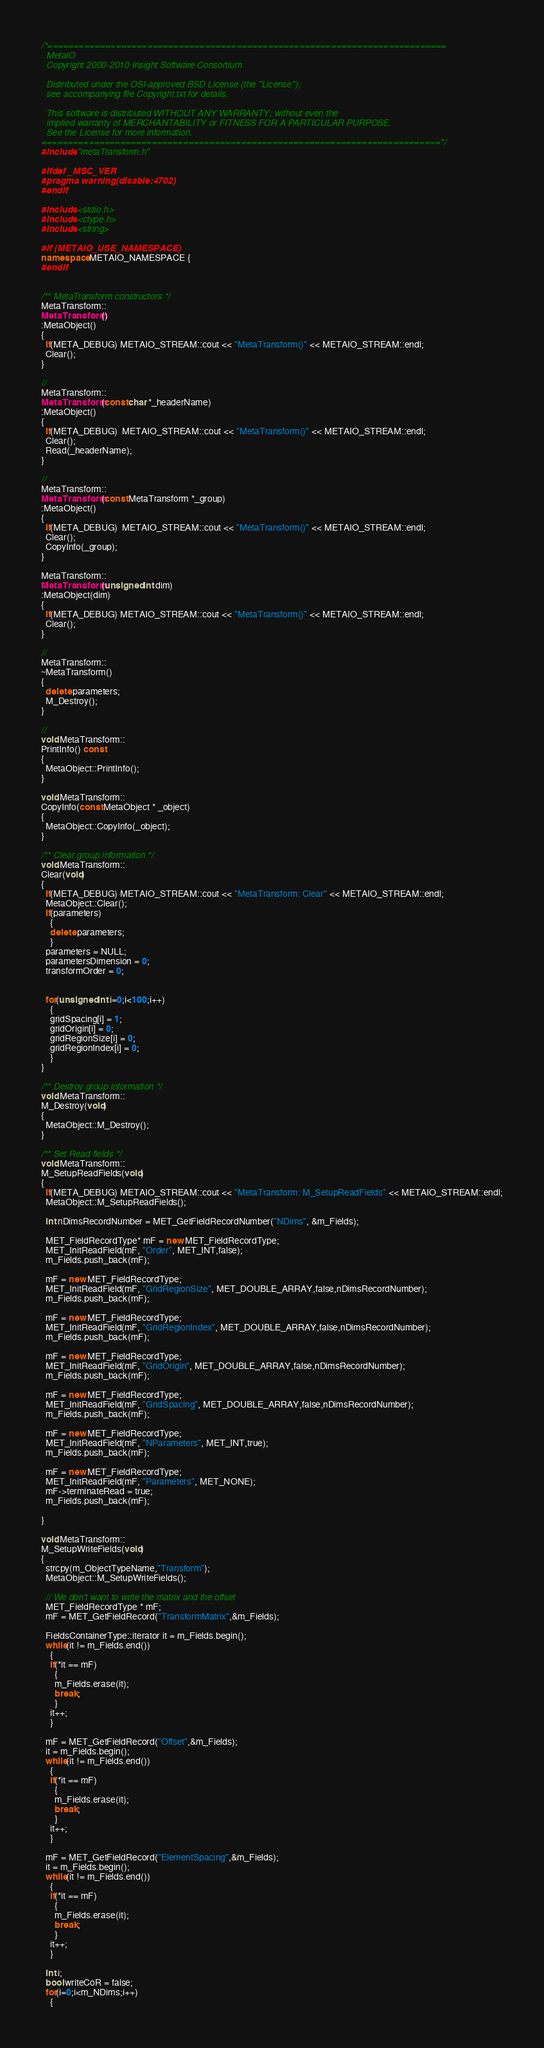Convert code to text. <code><loc_0><loc_0><loc_500><loc_500><_C++_>/*============================================================================
  MetaIO
  Copyright 2000-2010 Insight Software Consortium

  Distributed under the OSI-approved BSD License (the "License");
  see accompanying file Copyright.txt for details.

  This software is distributed WITHOUT ANY WARRANTY; without even the
  implied warranty of MERCHANTABILITY or FITNESS FOR A PARTICULAR PURPOSE.
  See the License for more information.
============================================================================*/
#include "metaTransform.h"

#ifdef _MSC_VER
#pragma warning(disable:4702)
#endif

#include <stdio.h>
#include <ctype.h>
#include <string>

#if (METAIO_USE_NAMESPACE)
namespace METAIO_NAMESPACE {
#endif


/** MetaTransform constructors */
MetaTransform::
MetaTransform()
:MetaObject()
{
  if(META_DEBUG) METAIO_STREAM::cout << "MetaTransform()" << METAIO_STREAM::endl;
  Clear();
}

//
MetaTransform::
MetaTransform(const char *_headerName)
:MetaObject()
{
  if(META_DEBUG)  METAIO_STREAM::cout << "MetaTransform()" << METAIO_STREAM::endl;
  Clear();
  Read(_headerName);
}

//
MetaTransform::
MetaTransform(const MetaTransform *_group)
:MetaObject()
{
  if(META_DEBUG)  METAIO_STREAM::cout << "MetaTransform()" << METAIO_STREAM::endl;
  Clear();
  CopyInfo(_group);
}

MetaTransform::
MetaTransform(unsigned int dim)
:MetaObject(dim)
{
  if(META_DEBUG) METAIO_STREAM::cout << "MetaTransform()" << METAIO_STREAM::endl;
  Clear();
}

//
MetaTransform::
~MetaTransform()
{
  delete parameters;
  M_Destroy();
}

//
void MetaTransform::
PrintInfo() const
{
  MetaObject::PrintInfo();
}

void MetaTransform::
CopyInfo(const MetaObject * _object)
{
  MetaObject::CopyInfo(_object);
}

/** Clear group information */
void MetaTransform::
Clear(void)
{
  if(META_DEBUG) METAIO_STREAM::cout << "MetaTransform: Clear" << METAIO_STREAM::endl;
  MetaObject::Clear();
  if(parameters)
    {
    delete parameters;
    }
  parameters = NULL;
  parametersDimension = 0;
  transformOrder = 0;


  for(unsigned int i=0;i<100;i++)
    {
    gridSpacing[i] = 1;
    gridOrigin[i] = 0;
    gridRegionSize[i] = 0;
    gridRegionIndex[i] = 0;
    }
}
        
/** Destroy group information */
void MetaTransform::
M_Destroy(void)
{
  MetaObject::M_Destroy();
}

/** Set Read fields */
void MetaTransform::
M_SetupReadFields(void)
{
  if(META_DEBUG) METAIO_STREAM::cout << "MetaTransform: M_SetupReadFields" << METAIO_STREAM::endl;
  MetaObject::M_SetupReadFields();

  int nDimsRecordNumber = MET_GetFieldRecordNumber("NDims", &m_Fields);
  
  MET_FieldRecordType* mF = new MET_FieldRecordType;
  MET_InitReadField(mF, "Order", MET_INT,false);
  m_Fields.push_back(mF);

  mF = new MET_FieldRecordType;
  MET_InitReadField(mF, "GridRegionSize", MET_DOUBLE_ARRAY,false,nDimsRecordNumber);
  m_Fields.push_back(mF);
  
  mF = new MET_FieldRecordType;
  MET_InitReadField(mF, "GridRegionIndex", MET_DOUBLE_ARRAY,false,nDimsRecordNumber);
  m_Fields.push_back(mF);
  
  mF = new MET_FieldRecordType;
  MET_InitReadField(mF, "GridOrigin", MET_DOUBLE_ARRAY,false,nDimsRecordNumber);
  m_Fields.push_back(mF);
  
  mF = new MET_FieldRecordType;
  MET_InitReadField(mF, "GridSpacing", MET_DOUBLE_ARRAY,false,nDimsRecordNumber);
  m_Fields.push_back(mF);

  mF = new MET_FieldRecordType;
  MET_InitReadField(mF, "NParameters", MET_INT,true);
  m_Fields.push_back(mF);

  mF = new MET_FieldRecordType;
  MET_InitReadField(mF, "Parameters", MET_NONE);
  mF->terminateRead = true;
  m_Fields.push_back(mF);
    
}

void MetaTransform::
M_SetupWriteFields(void)
{
  strcpy(m_ObjectTypeName,"Transform");
  MetaObject::M_SetupWriteFields();

  // We don't want to write the matrix and the offset
  MET_FieldRecordType * mF;
  mF = MET_GetFieldRecord("TransformMatrix",&m_Fields);

  FieldsContainerType::iterator it = m_Fields.begin();
  while(it != m_Fields.end())
    {
    if(*it == mF)
      {
      m_Fields.erase(it);
      break;
      }
    it++;
    }

  mF = MET_GetFieldRecord("Offset",&m_Fields);
  it = m_Fields.begin();
  while(it != m_Fields.end())
    {
    if(*it == mF)
      {
      m_Fields.erase(it);
      break;
      }
    it++;
    }

  mF = MET_GetFieldRecord("ElementSpacing",&m_Fields);
  it = m_Fields.begin();
  while(it != m_Fields.end())
    {
    if(*it == mF)
      {
      m_Fields.erase(it);
      break;
      }
    it++;
    }

  int i;
  bool writeCoR = false;
  for(i=0;i<m_NDims;i++)
    {</code> 